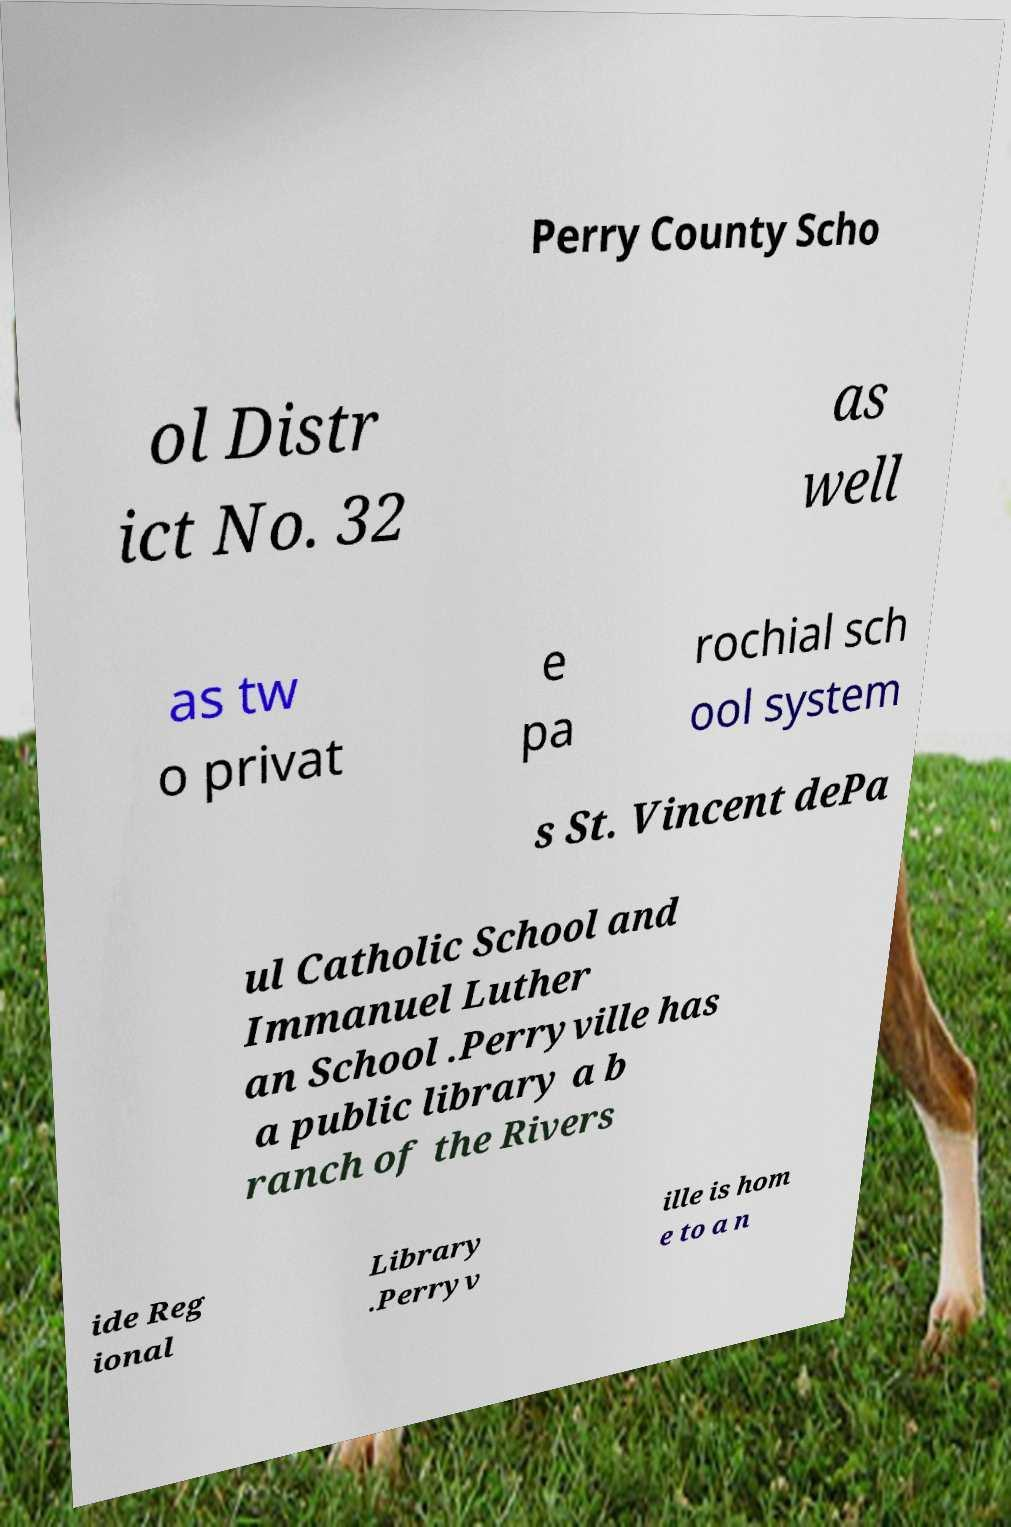Could you extract and type out the text from this image? Perry County Scho ol Distr ict No. 32 as well as tw o privat e pa rochial sch ool system s St. Vincent dePa ul Catholic School and Immanuel Luther an School .Perryville has a public library a b ranch of the Rivers ide Reg ional Library .Perryv ille is hom e to a n 